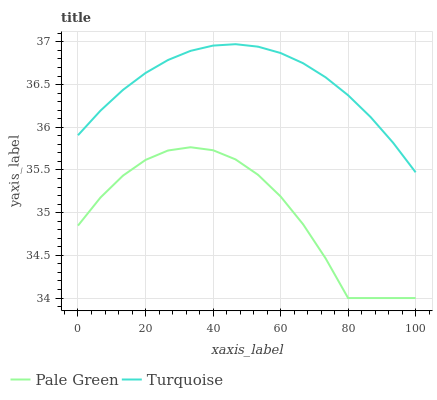Does Pale Green have the maximum area under the curve?
Answer yes or no. No. Is Pale Green the smoothest?
Answer yes or no. No. Does Pale Green have the highest value?
Answer yes or no. No. Is Pale Green less than Turquoise?
Answer yes or no. Yes. Is Turquoise greater than Pale Green?
Answer yes or no. Yes. Does Pale Green intersect Turquoise?
Answer yes or no. No. 